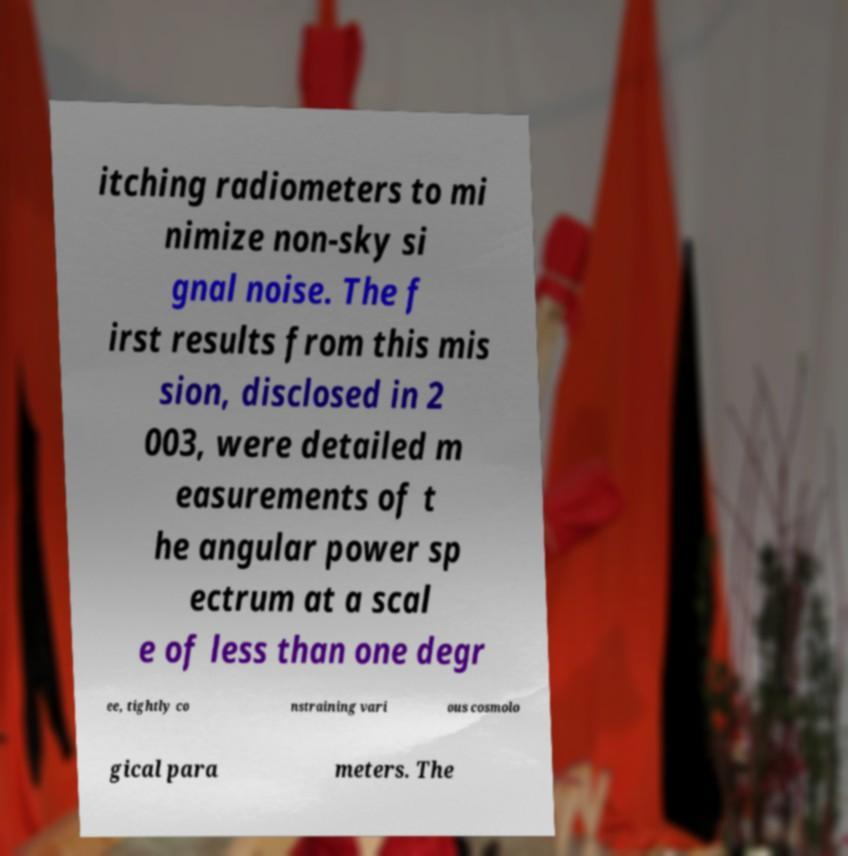What messages or text are displayed in this image? I need them in a readable, typed format. itching radiometers to mi nimize non-sky si gnal noise. The f irst results from this mis sion, disclosed in 2 003, were detailed m easurements of t he angular power sp ectrum at a scal e of less than one degr ee, tightly co nstraining vari ous cosmolo gical para meters. The 